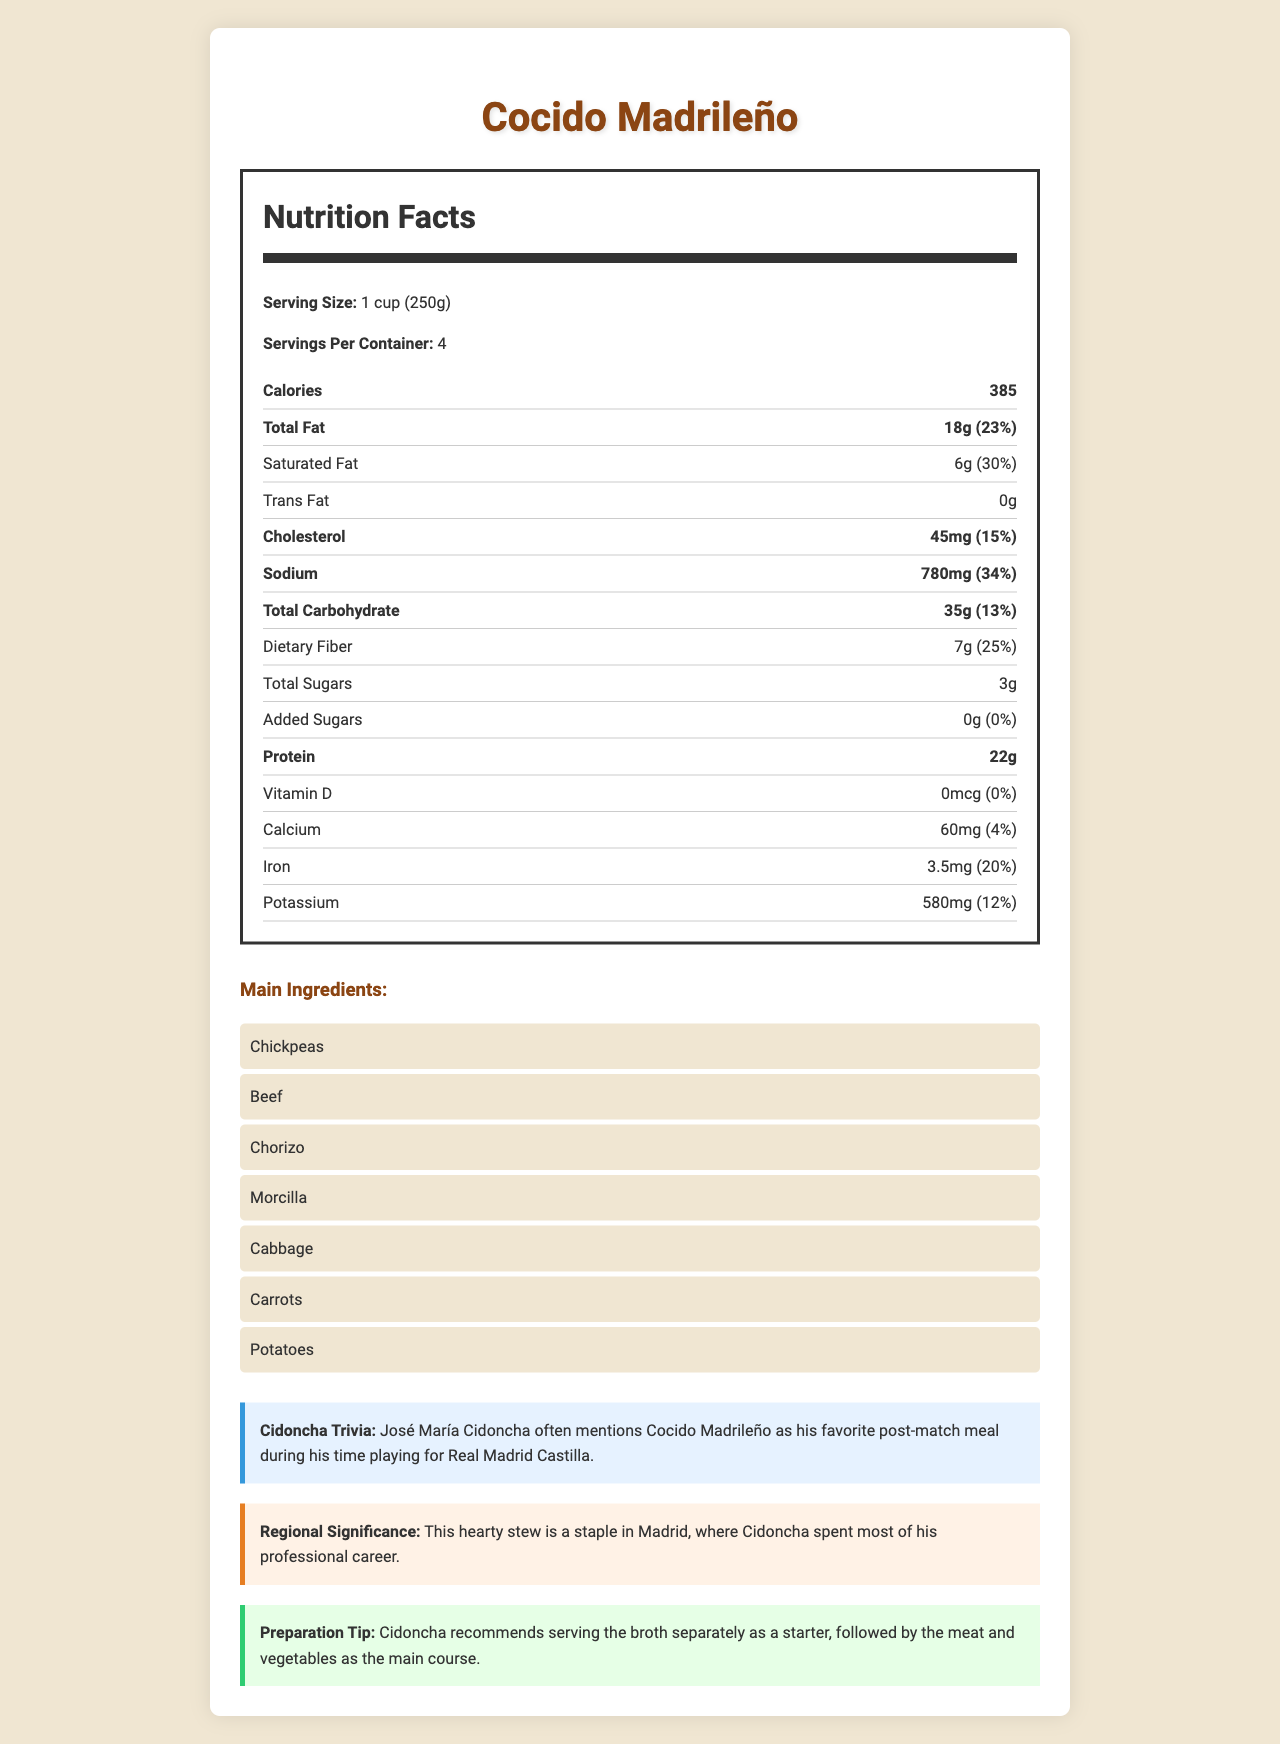what is the serving size described in the document? The serving size is clearly mentioned under the Nutrition Facts section as 1 cup, which is equivalent to 250 grams.
Answer: 1 cup (250g) how many servings are there per container? The document states that there are 4 servings per container.
Answer: 4 what is the amount of total fat per serving? It is stated in the Nutrition Facts that the total fat amount per serving is 18 grams.
Answer: 18g how much protein does one serving contain? The Nutrition Facts section shows that one serving contains 22 grams of protein.
Answer: 22g is there any trans fat in Cocido Madrileño? The Nutrition Facts indicate that the amount of trans fat is 0 grams.
Answer: No what is José María Cidoncha's recommended way to serve Cocido Madrileño? A. Serve all ingredients together B. Serve broth separately, then meat and vegetables C. Serve meat and vegetables together, followed by broth D. Mix everything and serve Cidoncha recommends in the Preparation Tip to serve the broth separately as a starter, followed by the meat and vegetables as the main course.
Answer: B how many calories are in one serving of Cocido Madrileño? The Nutrition Facts specify that one serving contains 385 calories.
Answer: 385 what are the main ingredients of Cocido Madrileño? A. Chickpeas, Beef, Chorizo, Morcilla, Cabbage, Carrots, Potatoes B. Beans, Chicken, Chorizo, Blood Sausage, Spinach, Onions, Tomatoes C. Lentils, Pork, Salami, Morcilla, Kale, Beets, Yams D. Chickpeas, Lamb, Salami, Blood Sausage, Broccoli, Celery, Peppers The Main Ingredients list includes Chickpeas, Beef, Chorizo, Morcilla, Cabbage, Carrots, and Potatoes.
Answer: A is Cocido Madrileño high in dietary fiber? With 7 grams of dietary fiber per serving which is 25% of the daily value, Cocido Madrileño is high in dietary fiber.
Answer: Yes summarize the purpose of this document This document serves to inform readers about the nutritional content and cultural significance of Cocido Madrileño, a dish often mentioned by José María Cidoncha.
Answer: The document provides detailed nutritional information about Cocido Madrileño, a traditional Spanish dish. It includes the serving size, calories, and a breakdown of various nutrients per serving. Additionally, it mentions the main ingredients, a trivia note about José María Cidoncha, the regional significance of the dish, and a preparation tip. what percentage of the daily value of sodium does one serving of Cocido Madrileño contain? The Nutrition Facts state that one serving contains 780 mg of sodium, which is 34% of the daily value.
Answer: 34% what is the daily value percentage of cholesterol in each serving? According to the document, one serving has 45 mg of cholesterol, which is 15% of the daily value.
Answer: 15% what note is associated with José María Cidoncha and Cocido Madrileño? This note can be found in the Cidoncha Trivia section of the document.
Answer: José María Cidoncha often mentions Cocido Madrileño as his favorite post-match meal during his time playing for Real Madrid Castilla. can the vitamin D content of Cocido Madrileño be determined from the document? The document states that the amount of vitamin D is 0 mcg with 0% daily value.
Answer: Yes which element has the highest daily value percentage in one serving of Cocido Madrileño? A. Total Fat B. Sodium C. Protein D. Dietary Fiber Sodium has the highest daily value percentage at 34%.
Answer: B does Cocido Madrileño contain any added sugars? The Nutrition Facts indicate that there are 0 grams of added sugars and 0% daily value.
Answer: No how should someone with a high sodium diet concern interpret the document? The daily value percentage for sodium is prominently listed as 34%, indicating a higher sodium content.
Answer: The document suggests that each serving of Cocido Madrileño contains a relatively high amount of sodium, accounting for 34% of the daily value, which might be a concern for those monitoring their sodium intake. where did José María Cidoncha spend most of his professional career? The Regional Significance section mentions that Cocido Madrileño is a staple in Madrid, where Cidoncha spent most of his professional career.
Answer: Madrid what specific culinary tip does José María Cidoncha give for preparing Cocido Madrileño? The document's Preparation Tip section outlines this method.
Answer: Cidoncha recommends serving the broth separately as a starter, followed by the meat and vegetables as the main course. 